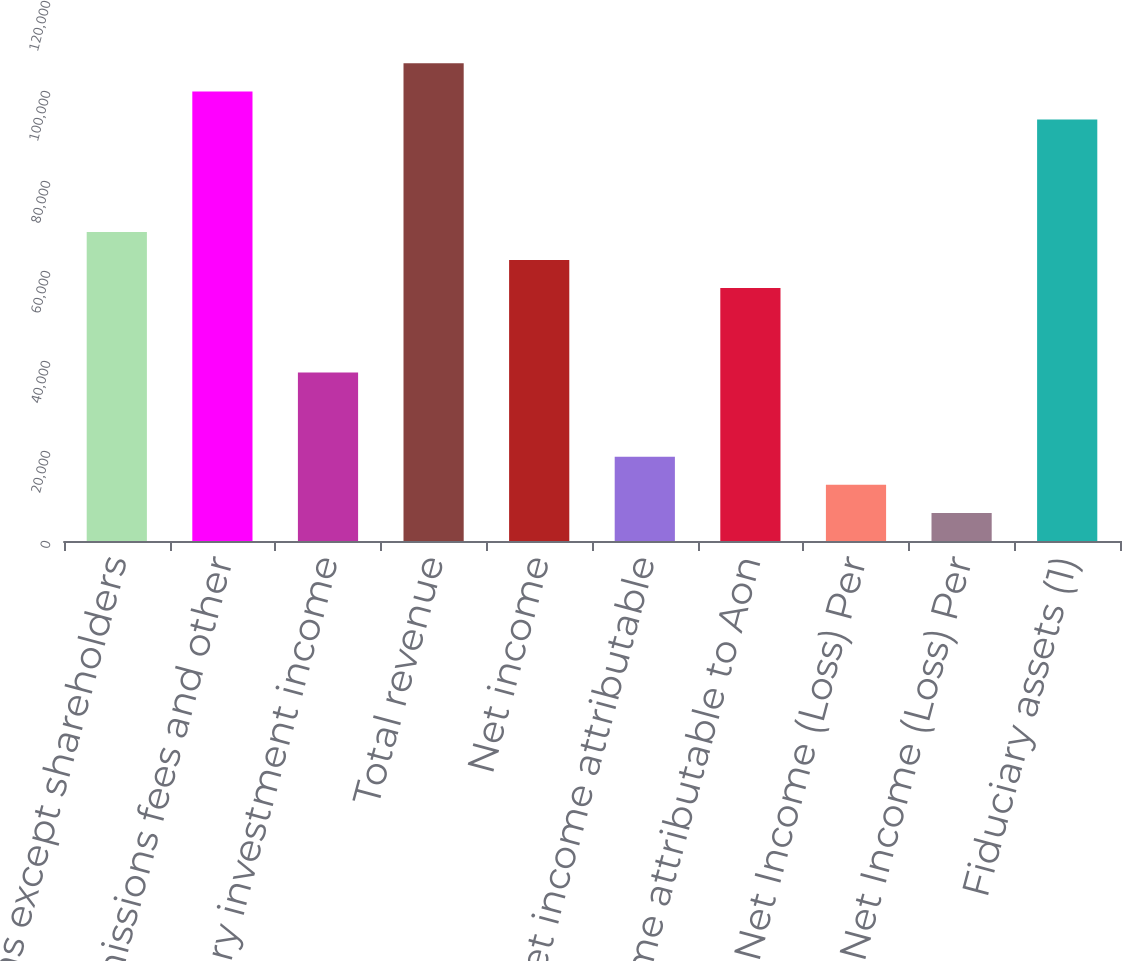<chart> <loc_0><loc_0><loc_500><loc_500><bar_chart><fcel>(millions except shareholders<fcel>Commissions fees and other<fcel>Fiduciary investment income<fcel>Total revenue<fcel>Net income<fcel>Less Net income attributable<fcel>Net income attributable to Aon<fcel>Basic Net Income (Loss) Per<fcel>Diluted Net Income (Loss) Per<fcel>Fiduciary assets (1)<nl><fcel>68687.2<fcel>99908.4<fcel>37466<fcel>106153<fcel>62443<fcel>18733.3<fcel>56198.8<fcel>12489.1<fcel>6244.84<fcel>93664.2<nl></chart> 